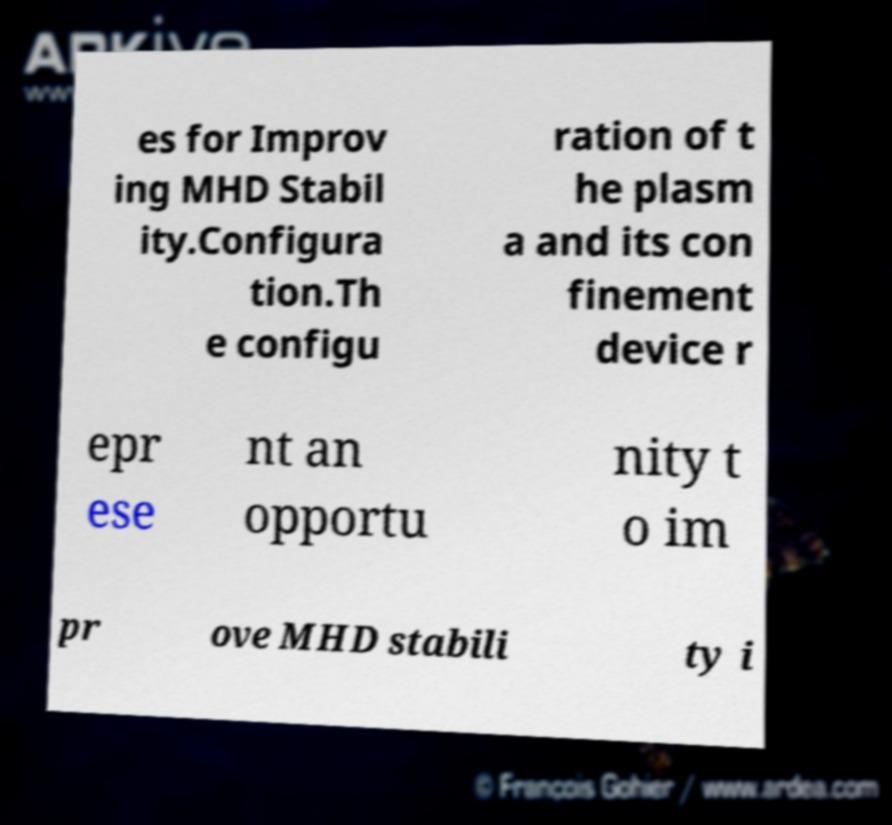Can you accurately transcribe the text from the provided image for me? es for Improv ing MHD Stabil ity.Configura tion.Th e configu ration of t he plasm a and its con finement device r epr ese nt an opportu nity t o im pr ove MHD stabili ty i 